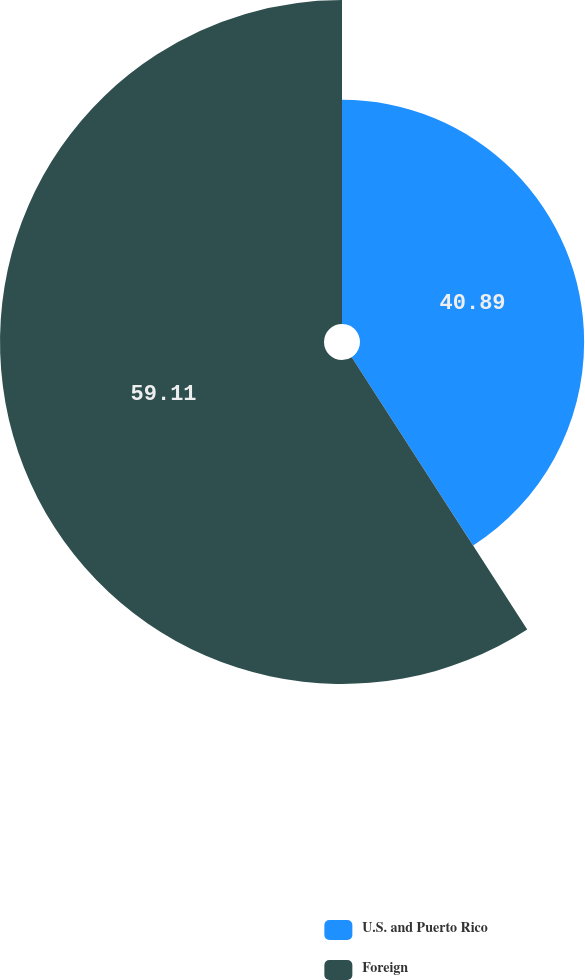<chart> <loc_0><loc_0><loc_500><loc_500><pie_chart><fcel>U.S. and Puerto Rico<fcel>Foreign<nl><fcel>40.89%<fcel>59.11%<nl></chart> 